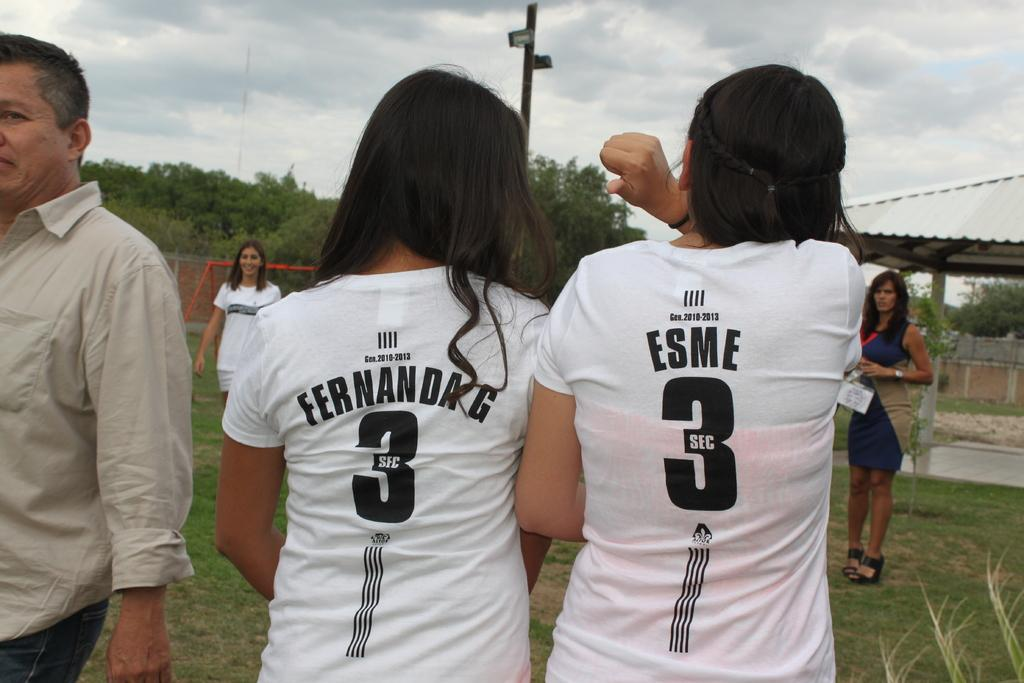<image>
Describe the image concisely. two girls with black hair wearing white shirts with a 3 on the back with sec in the 3 